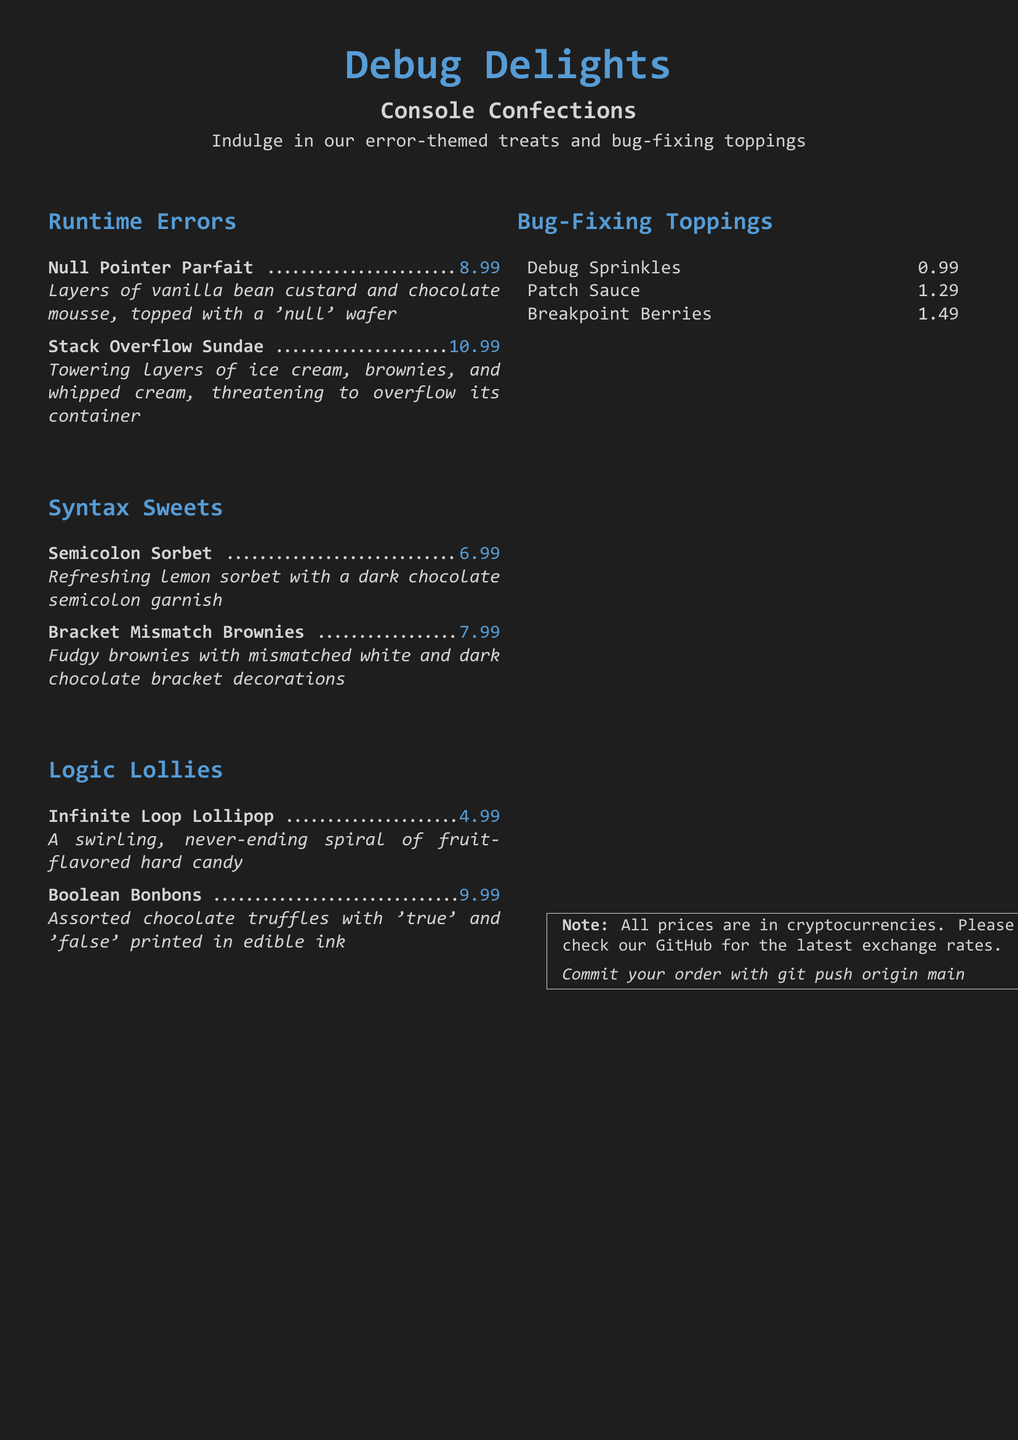What is the title of the dessert menu? The title of the dessert menu is displayed at the top of the document as "Debug Delights".
Answer: Debug Delights How much does the Stack Overflow Sundae cost? The cost of the Stack Overflow Sundae is listed next to the item description in the menu.
Answer: 10.99 What is the main ingredient in the Null Pointer Parfait? The main ingredients are specified in the item description, highlighting layers of vanilla bean custard and chocolate mousse.
Answer: vanilla bean custard and chocolate mousse Which treat has a fruit-flavored design? The design of the Infinite Loop Lollipop is specified as a swirling, never-ending spiral of fruit flavors.
Answer: Infinite Loop Lollipop What are the Bug-Fixing Toppings? The document lists Debug Sprinkles, Patch Sauce, and Breakpoint Berries under Bug-Fixing Toppings.
Answer: Debug Sprinkles, Patch Sauce, Breakpoint Berries What is the price of the Semicolon Sorbet? The price is given right after the item name in the dessert menu.
Answer: 6.99 Which sweet is described with the term "mismatched"? The treat described with "mismatched" is outlined in the item description as having conflicting chocolate decorations.
Answer: Bracket Mismatch Brownies What should customers do to commit their order? The menu includes a playful command related to version control, instructing clients on how to finalize their order.
Answer: git push origin main 